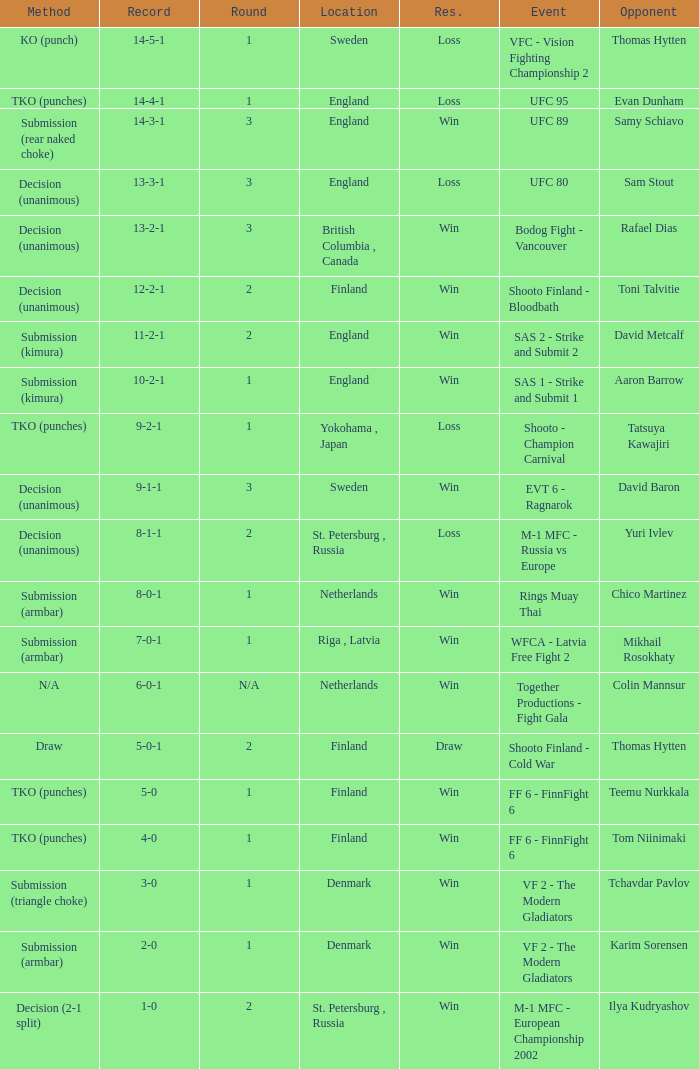Who was the opponent with a record of 14-4-1 and has a round of 1? Evan Dunham. Help me parse the entirety of this table. {'header': ['Method', 'Record', 'Round', 'Location', 'Res.', 'Event', 'Opponent'], 'rows': [['KO (punch)', '14-5-1', '1', 'Sweden', 'Loss', 'VFC - Vision Fighting Championship 2', 'Thomas Hytten'], ['TKO (punches)', '14-4-1', '1', 'England', 'Loss', 'UFC 95', 'Evan Dunham'], ['Submission (rear naked choke)', '14-3-1', '3', 'England', 'Win', 'UFC 89', 'Samy Schiavo'], ['Decision (unanimous)', '13-3-1', '3', 'England', 'Loss', 'UFC 80', 'Sam Stout'], ['Decision (unanimous)', '13-2-1', '3', 'British Columbia , Canada', 'Win', 'Bodog Fight - Vancouver', 'Rafael Dias'], ['Decision (unanimous)', '12-2-1', '2', 'Finland', 'Win', 'Shooto Finland - Bloodbath', 'Toni Talvitie'], ['Submission (kimura)', '11-2-1', '2', 'England', 'Win', 'SAS 2 - Strike and Submit 2', 'David Metcalf'], ['Submission (kimura)', '10-2-1', '1', 'England', 'Win', 'SAS 1 - Strike and Submit 1', 'Aaron Barrow'], ['TKO (punches)', '9-2-1', '1', 'Yokohama , Japan', 'Loss', 'Shooto - Champion Carnival', 'Tatsuya Kawajiri'], ['Decision (unanimous)', '9-1-1', '3', 'Sweden', 'Win', 'EVT 6 - Ragnarok', 'David Baron'], ['Decision (unanimous)', '8-1-1', '2', 'St. Petersburg , Russia', 'Loss', 'M-1 MFC - Russia vs Europe', 'Yuri Ivlev'], ['Submission (armbar)', '8-0-1', '1', 'Netherlands', 'Win', 'Rings Muay Thai', 'Chico Martinez'], ['Submission (armbar)', '7-0-1', '1', 'Riga , Latvia', 'Win', 'WFCA - Latvia Free Fight 2', 'Mikhail Rosokhaty'], ['N/A', '6-0-1', 'N/A', 'Netherlands', 'Win', 'Together Productions - Fight Gala', 'Colin Mannsur'], ['Draw', '5-0-1', '2', 'Finland', 'Draw', 'Shooto Finland - Cold War', 'Thomas Hytten'], ['TKO (punches)', '5-0', '1', 'Finland', 'Win', 'FF 6 - FinnFight 6', 'Teemu Nurkkala'], ['TKO (punches)', '4-0', '1', 'Finland', 'Win', 'FF 6 - FinnFight 6', 'Tom Niinimaki'], ['Submission (triangle choke)', '3-0', '1', 'Denmark', 'Win', 'VF 2 - The Modern Gladiators', 'Tchavdar Pavlov'], ['Submission (armbar)', '2-0', '1', 'Denmark', 'Win', 'VF 2 - The Modern Gladiators', 'Karim Sorensen'], ['Decision (2-1 split)', '1-0', '2', 'St. Petersburg , Russia', 'Win', 'M-1 MFC - European Championship 2002', 'Ilya Kudryashov']]} 